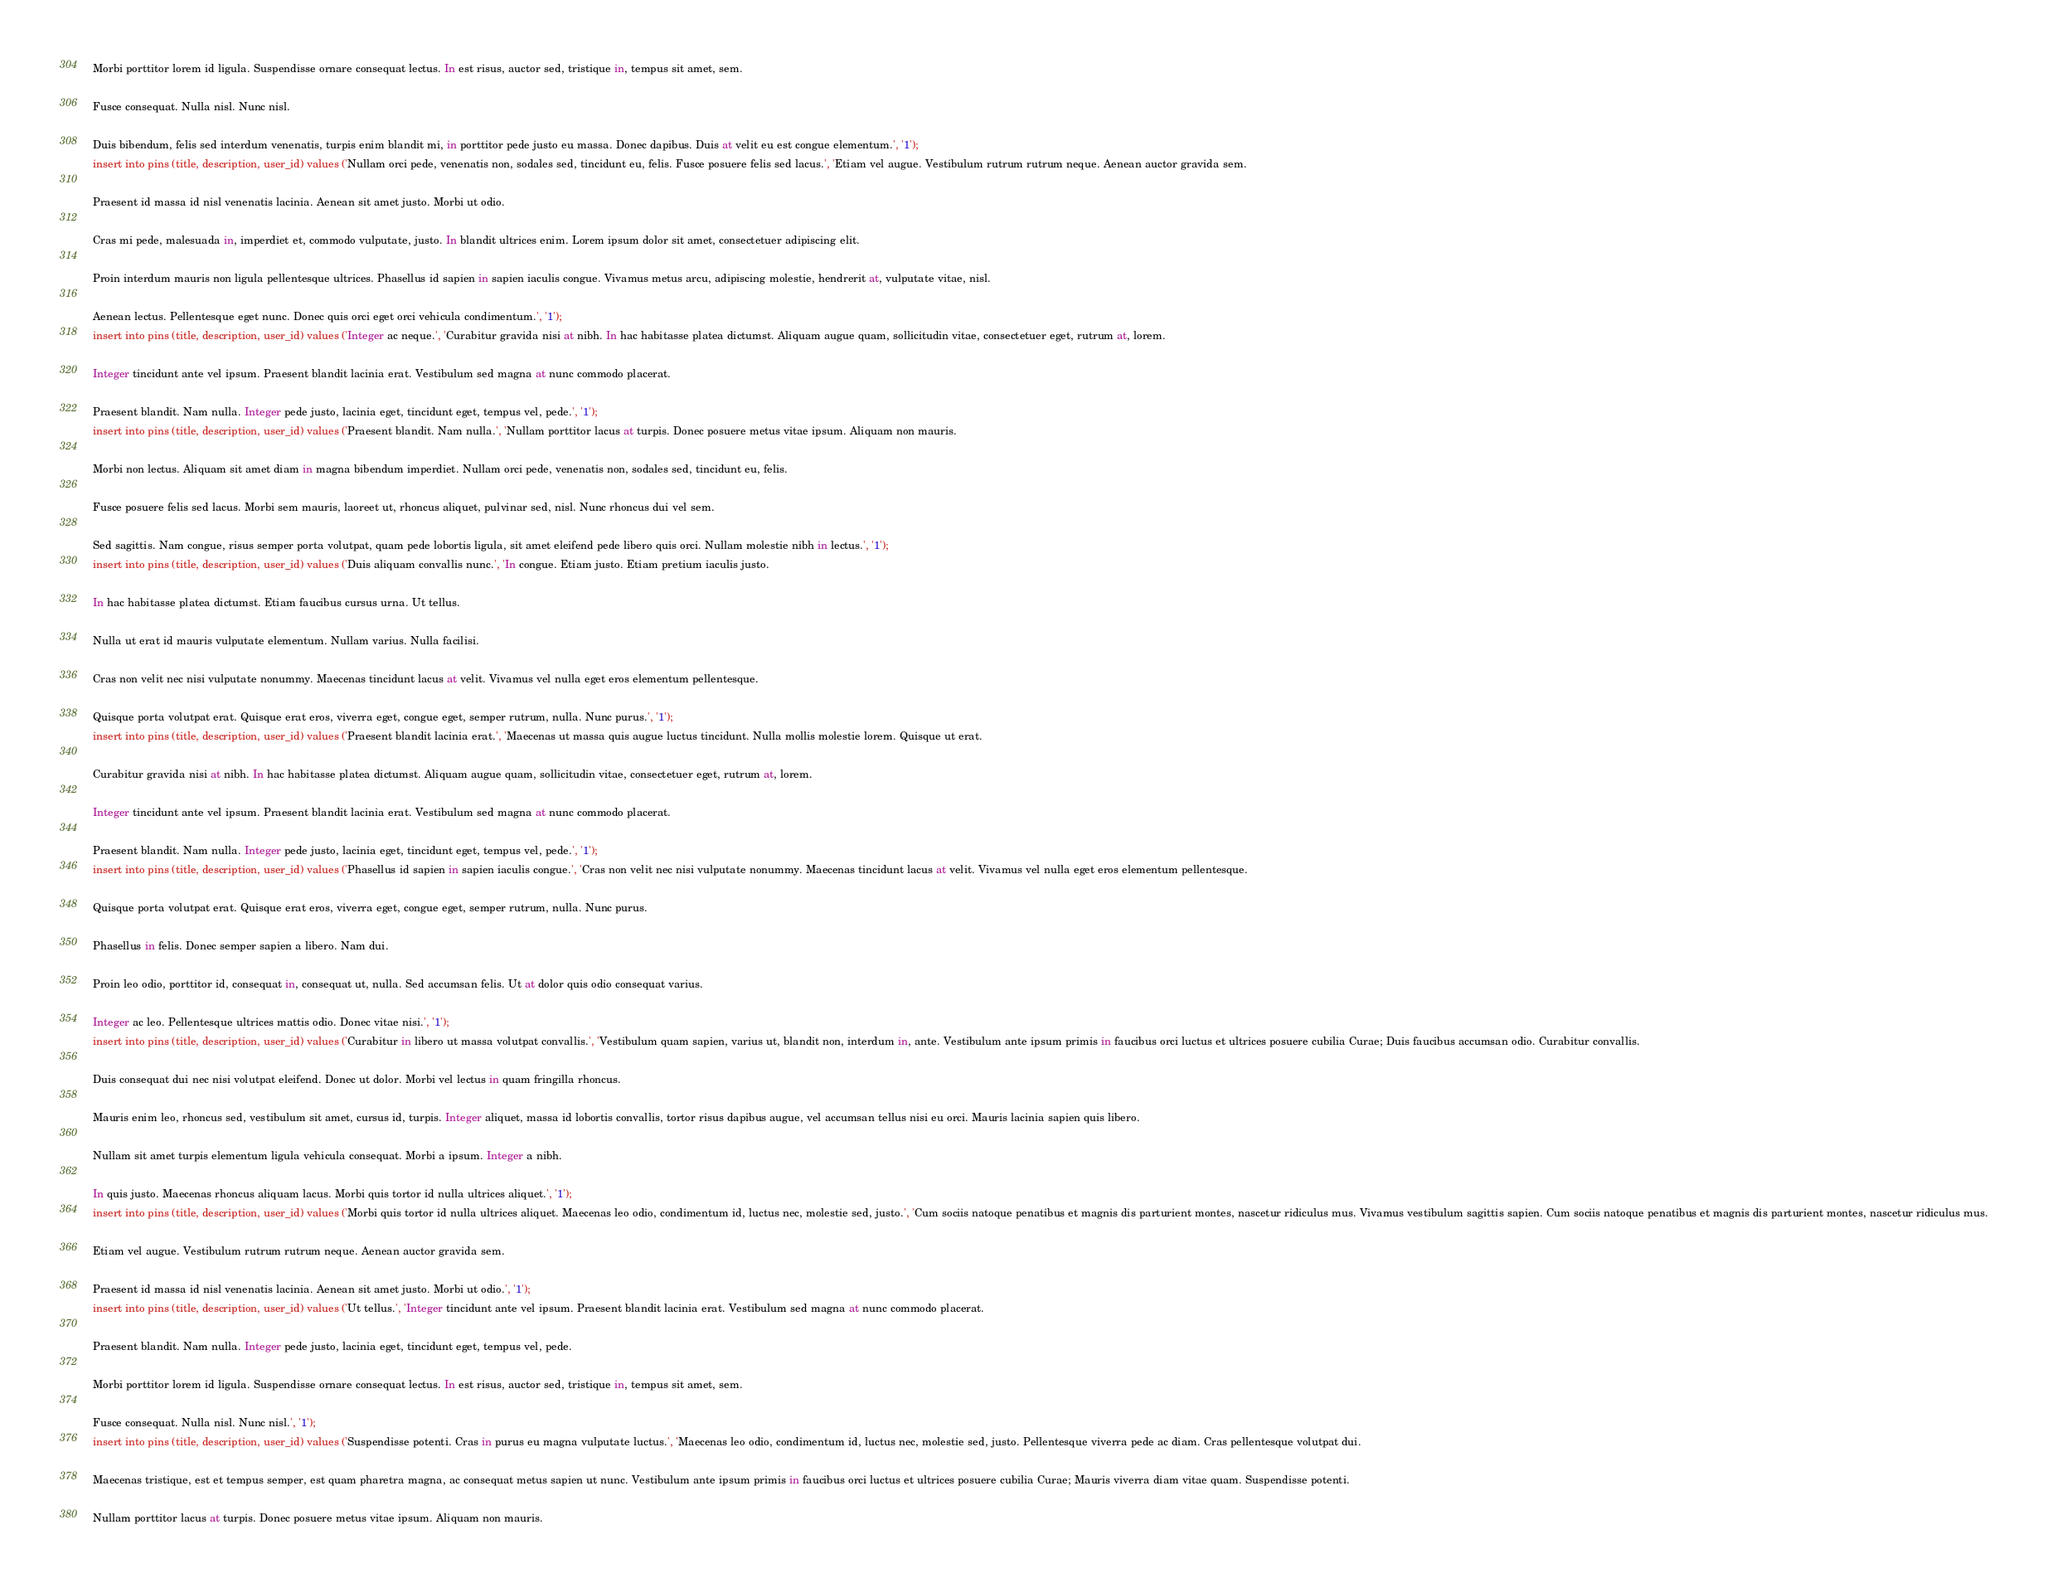Convert code to text. <code><loc_0><loc_0><loc_500><loc_500><_SQL_>
Morbi porttitor lorem id ligula. Suspendisse ornare consequat lectus. In est risus, auctor sed, tristique in, tempus sit amet, sem.

Fusce consequat. Nulla nisl. Nunc nisl.

Duis bibendum, felis sed interdum venenatis, turpis enim blandit mi, in porttitor pede justo eu massa. Donec dapibus. Duis at velit eu est congue elementum.', '1');
insert into pins (title, description, user_id) values ('Nullam orci pede, venenatis non, sodales sed, tincidunt eu, felis. Fusce posuere felis sed lacus.', 'Etiam vel augue. Vestibulum rutrum rutrum neque. Aenean auctor gravida sem.

Praesent id massa id nisl venenatis lacinia. Aenean sit amet justo. Morbi ut odio.

Cras mi pede, malesuada in, imperdiet et, commodo vulputate, justo. In blandit ultrices enim. Lorem ipsum dolor sit amet, consectetuer adipiscing elit.

Proin interdum mauris non ligula pellentesque ultrices. Phasellus id sapien in sapien iaculis congue. Vivamus metus arcu, adipiscing molestie, hendrerit at, vulputate vitae, nisl.

Aenean lectus. Pellentesque eget nunc. Donec quis orci eget orci vehicula condimentum.', '1');
insert into pins (title, description, user_id) values ('Integer ac neque.', 'Curabitur gravida nisi at nibh. In hac habitasse platea dictumst. Aliquam augue quam, sollicitudin vitae, consectetuer eget, rutrum at, lorem.

Integer tincidunt ante vel ipsum. Praesent blandit lacinia erat. Vestibulum sed magna at nunc commodo placerat.

Praesent blandit. Nam nulla. Integer pede justo, lacinia eget, tincidunt eget, tempus vel, pede.', '1');
insert into pins (title, description, user_id) values ('Praesent blandit. Nam nulla.', 'Nullam porttitor lacus at turpis. Donec posuere metus vitae ipsum. Aliquam non mauris.

Morbi non lectus. Aliquam sit amet diam in magna bibendum imperdiet. Nullam orci pede, venenatis non, sodales sed, tincidunt eu, felis.

Fusce posuere felis sed lacus. Morbi sem mauris, laoreet ut, rhoncus aliquet, pulvinar sed, nisl. Nunc rhoncus dui vel sem.

Sed sagittis. Nam congue, risus semper porta volutpat, quam pede lobortis ligula, sit amet eleifend pede libero quis orci. Nullam molestie nibh in lectus.', '1');
insert into pins (title, description, user_id) values ('Duis aliquam convallis nunc.', 'In congue. Etiam justo. Etiam pretium iaculis justo.

In hac habitasse platea dictumst. Etiam faucibus cursus urna. Ut tellus.

Nulla ut erat id mauris vulputate elementum. Nullam varius. Nulla facilisi.

Cras non velit nec nisi vulputate nonummy. Maecenas tincidunt lacus at velit. Vivamus vel nulla eget eros elementum pellentesque.

Quisque porta volutpat erat. Quisque erat eros, viverra eget, congue eget, semper rutrum, nulla. Nunc purus.', '1');
insert into pins (title, description, user_id) values ('Praesent blandit lacinia erat.', 'Maecenas ut massa quis augue luctus tincidunt. Nulla mollis molestie lorem. Quisque ut erat.

Curabitur gravida nisi at nibh. In hac habitasse platea dictumst. Aliquam augue quam, sollicitudin vitae, consectetuer eget, rutrum at, lorem.

Integer tincidunt ante vel ipsum. Praesent blandit lacinia erat. Vestibulum sed magna at nunc commodo placerat.

Praesent blandit. Nam nulla. Integer pede justo, lacinia eget, tincidunt eget, tempus vel, pede.', '1');
insert into pins (title, description, user_id) values ('Phasellus id sapien in sapien iaculis congue.', 'Cras non velit nec nisi vulputate nonummy. Maecenas tincidunt lacus at velit. Vivamus vel nulla eget eros elementum pellentesque.

Quisque porta volutpat erat. Quisque erat eros, viverra eget, congue eget, semper rutrum, nulla. Nunc purus.

Phasellus in felis. Donec semper sapien a libero. Nam dui.

Proin leo odio, porttitor id, consequat in, consequat ut, nulla. Sed accumsan felis. Ut at dolor quis odio consequat varius.

Integer ac leo. Pellentesque ultrices mattis odio. Donec vitae nisi.', '1');
insert into pins (title, description, user_id) values ('Curabitur in libero ut massa volutpat convallis.', 'Vestibulum quam sapien, varius ut, blandit non, interdum in, ante. Vestibulum ante ipsum primis in faucibus orci luctus et ultrices posuere cubilia Curae; Duis faucibus accumsan odio. Curabitur convallis.

Duis consequat dui nec nisi volutpat eleifend. Donec ut dolor. Morbi vel lectus in quam fringilla rhoncus.

Mauris enim leo, rhoncus sed, vestibulum sit amet, cursus id, turpis. Integer aliquet, massa id lobortis convallis, tortor risus dapibus augue, vel accumsan tellus nisi eu orci. Mauris lacinia sapien quis libero.

Nullam sit amet turpis elementum ligula vehicula consequat. Morbi a ipsum. Integer a nibh.

In quis justo. Maecenas rhoncus aliquam lacus. Morbi quis tortor id nulla ultrices aliquet.', '1');
insert into pins (title, description, user_id) values ('Morbi quis tortor id nulla ultrices aliquet. Maecenas leo odio, condimentum id, luctus nec, molestie sed, justo.', 'Cum sociis natoque penatibus et magnis dis parturient montes, nascetur ridiculus mus. Vivamus vestibulum sagittis sapien. Cum sociis natoque penatibus et magnis dis parturient montes, nascetur ridiculus mus.

Etiam vel augue. Vestibulum rutrum rutrum neque. Aenean auctor gravida sem.

Praesent id massa id nisl venenatis lacinia. Aenean sit amet justo. Morbi ut odio.', '1');
insert into pins (title, description, user_id) values ('Ut tellus.', 'Integer tincidunt ante vel ipsum. Praesent blandit lacinia erat. Vestibulum sed magna at nunc commodo placerat.

Praesent blandit. Nam nulla. Integer pede justo, lacinia eget, tincidunt eget, tempus vel, pede.

Morbi porttitor lorem id ligula. Suspendisse ornare consequat lectus. In est risus, auctor sed, tristique in, tempus sit amet, sem.

Fusce consequat. Nulla nisl. Nunc nisl.', '1');
insert into pins (title, description, user_id) values ('Suspendisse potenti. Cras in purus eu magna vulputate luctus.', 'Maecenas leo odio, condimentum id, luctus nec, molestie sed, justo. Pellentesque viverra pede ac diam. Cras pellentesque volutpat dui.

Maecenas tristique, est et tempus semper, est quam pharetra magna, ac consequat metus sapien ut nunc. Vestibulum ante ipsum primis in faucibus orci luctus et ultrices posuere cubilia Curae; Mauris viverra diam vitae quam. Suspendisse potenti.

Nullam porttitor lacus at turpis. Donec posuere metus vitae ipsum. Aliquam non mauris.
</code> 